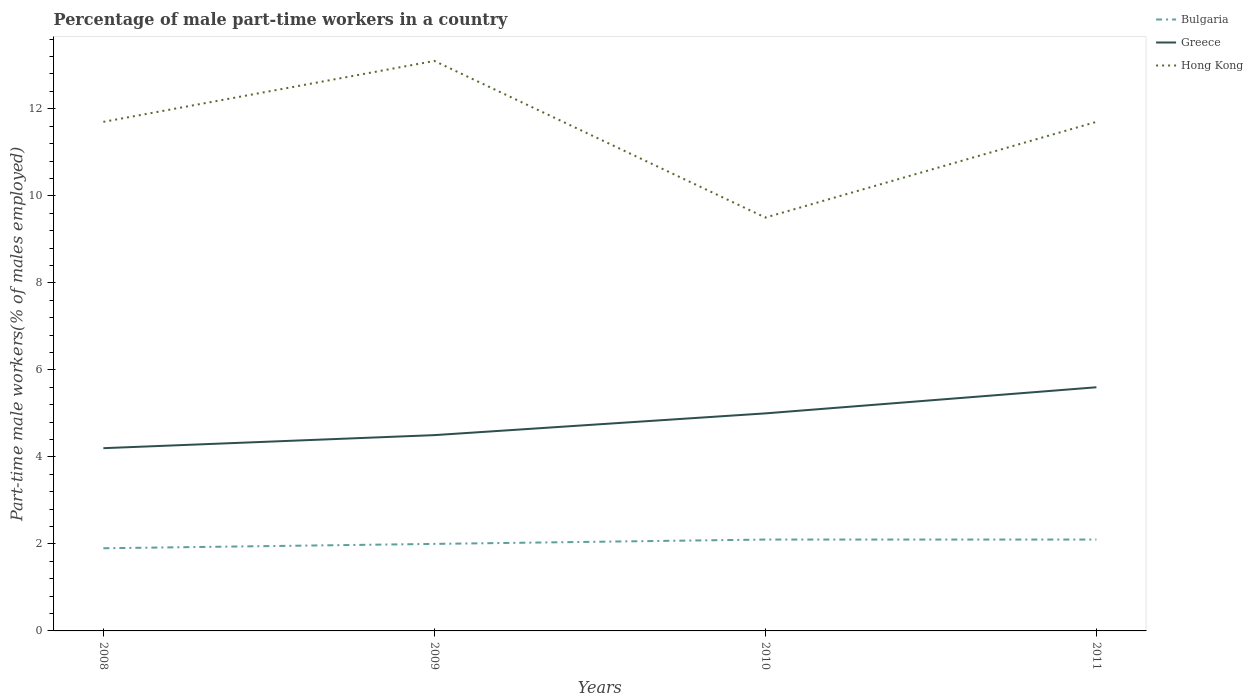How many different coloured lines are there?
Keep it short and to the point. 3. Does the line corresponding to Bulgaria intersect with the line corresponding to Hong Kong?
Make the answer very short. No. Is the number of lines equal to the number of legend labels?
Ensure brevity in your answer.  Yes. Across all years, what is the maximum percentage of male part-time workers in Bulgaria?
Ensure brevity in your answer.  1.9. In which year was the percentage of male part-time workers in Bulgaria maximum?
Your answer should be very brief. 2008. What is the total percentage of male part-time workers in Hong Kong in the graph?
Keep it short and to the point. 1.4. What is the difference between the highest and the second highest percentage of male part-time workers in Greece?
Provide a short and direct response. 1.4. How many years are there in the graph?
Offer a very short reply. 4. Does the graph contain grids?
Your answer should be very brief. No. What is the title of the graph?
Give a very brief answer. Percentage of male part-time workers in a country. What is the label or title of the Y-axis?
Your response must be concise. Part-time male workers(% of males employed). What is the Part-time male workers(% of males employed) in Bulgaria in 2008?
Provide a short and direct response. 1.9. What is the Part-time male workers(% of males employed) in Greece in 2008?
Offer a very short reply. 4.2. What is the Part-time male workers(% of males employed) in Hong Kong in 2008?
Provide a short and direct response. 11.7. What is the Part-time male workers(% of males employed) in Bulgaria in 2009?
Provide a short and direct response. 2. What is the Part-time male workers(% of males employed) in Greece in 2009?
Provide a succinct answer. 4.5. What is the Part-time male workers(% of males employed) in Hong Kong in 2009?
Make the answer very short. 13.1. What is the Part-time male workers(% of males employed) in Bulgaria in 2010?
Provide a short and direct response. 2.1. What is the Part-time male workers(% of males employed) of Hong Kong in 2010?
Your answer should be compact. 9.5. What is the Part-time male workers(% of males employed) in Bulgaria in 2011?
Keep it short and to the point. 2.1. What is the Part-time male workers(% of males employed) of Greece in 2011?
Ensure brevity in your answer.  5.6. What is the Part-time male workers(% of males employed) in Hong Kong in 2011?
Provide a short and direct response. 11.7. Across all years, what is the maximum Part-time male workers(% of males employed) in Bulgaria?
Keep it short and to the point. 2.1. Across all years, what is the maximum Part-time male workers(% of males employed) of Greece?
Offer a terse response. 5.6. Across all years, what is the maximum Part-time male workers(% of males employed) in Hong Kong?
Give a very brief answer. 13.1. Across all years, what is the minimum Part-time male workers(% of males employed) of Bulgaria?
Keep it short and to the point. 1.9. Across all years, what is the minimum Part-time male workers(% of males employed) in Greece?
Give a very brief answer. 4.2. What is the total Part-time male workers(% of males employed) of Greece in the graph?
Keep it short and to the point. 19.3. What is the total Part-time male workers(% of males employed) of Hong Kong in the graph?
Make the answer very short. 46. What is the difference between the Part-time male workers(% of males employed) in Greece in 2008 and that in 2009?
Make the answer very short. -0.3. What is the difference between the Part-time male workers(% of males employed) of Bulgaria in 2008 and that in 2011?
Provide a short and direct response. -0.2. What is the difference between the Part-time male workers(% of males employed) in Bulgaria in 2009 and that in 2010?
Your answer should be very brief. -0.1. What is the difference between the Part-time male workers(% of males employed) in Hong Kong in 2009 and that in 2010?
Offer a terse response. 3.6. What is the difference between the Part-time male workers(% of males employed) of Bulgaria in 2009 and that in 2011?
Provide a short and direct response. -0.1. What is the difference between the Part-time male workers(% of males employed) of Hong Kong in 2009 and that in 2011?
Provide a short and direct response. 1.4. What is the difference between the Part-time male workers(% of males employed) in Bulgaria in 2010 and that in 2011?
Your answer should be compact. 0. What is the difference between the Part-time male workers(% of males employed) of Greece in 2010 and that in 2011?
Provide a succinct answer. -0.6. What is the difference between the Part-time male workers(% of males employed) in Hong Kong in 2010 and that in 2011?
Your response must be concise. -2.2. What is the difference between the Part-time male workers(% of males employed) in Greece in 2008 and the Part-time male workers(% of males employed) in Hong Kong in 2009?
Offer a terse response. -8.9. What is the difference between the Part-time male workers(% of males employed) of Bulgaria in 2008 and the Part-time male workers(% of males employed) of Greece in 2010?
Your response must be concise. -3.1. What is the difference between the Part-time male workers(% of males employed) of Bulgaria in 2009 and the Part-time male workers(% of males employed) of Greece in 2010?
Your response must be concise. -3. What is the difference between the Part-time male workers(% of males employed) of Bulgaria in 2009 and the Part-time male workers(% of males employed) of Hong Kong in 2010?
Provide a short and direct response. -7.5. What is the difference between the Part-time male workers(% of males employed) of Greece in 2009 and the Part-time male workers(% of males employed) of Hong Kong in 2010?
Offer a very short reply. -5. What is the difference between the Part-time male workers(% of males employed) of Bulgaria in 2010 and the Part-time male workers(% of males employed) of Greece in 2011?
Provide a succinct answer. -3.5. What is the difference between the Part-time male workers(% of males employed) in Bulgaria in 2010 and the Part-time male workers(% of males employed) in Hong Kong in 2011?
Make the answer very short. -9.6. What is the average Part-time male workers(% of males employed) in Bulgaria per year?
Provide a succinct answer. 2.02. What is the average Part-time male workers(% of males employed) of Greece per year?
Your response must be concise. 4.83. What is the average Part-time male workers(% of males employed) of Hong Kong per year?
Keep it short and to the point. 11.5. In the year 2008, what is the difference between the Part-time male workers(% of males employed) in Bulgaria and Part-time male workers(% of males employed) in Hong Kong?
Ensure brevity in your answer.  -9.8. In the year 2008, what is the difference between the Part-time male workers(% of males employed) in Greece and Part-time male workers(% of males employed) in Hong Kong?
Offer a terse response. -7.5. In the year 2009, what is the difference between the Part-time male workers(% of males employed) of Bulgaria and Part-time male workers(% of males employed) of Greece?
Your answer should be compact. -2.5. In the year 2009, what is the difference between the Part-time male workers(% of males employed) of Greece and Part-time male workers(% of males employed) of Hong Kong?
Make the answer very short. -8.6. In the year 2010, what is the difference between the Part-time male workers(% of males employed) in Bulgaria and Part-time male workers(% of males employed) in Greece?
Your answer should be compact. -2.9. In the year 2011, what is the difference between the Part-time male workers(% of males employed) in Bulgaria and Part-time male workers(% of males employed) in Greece?
Keep it short and to the point. -3.5. In the year 2011, what is the difference between the Part-time male workers(% of males employed) in Bulgaria and Part-time male workers(% of males employed) in Hong Kong?
Offer a terse response. -9.6. What is the ratio of the Part-time male workers(% of males employed) of Bulgaria in 2008 to that in 2009?
Provide a short and direct response. 0.95. What is the ratio of the Part-time male workers(% of males employed) in Hong Kong in 2008 to that in 2009?
Give a very brief answer. 0.89. What is the ratio of the Part-time male workers(% of males employed) in Bulgaria in 2008 to that in 2010?
Make the answer very short. 0.9. What is the ratio of the Part-time male workers(% of males employed) in Greece in 2008 to that in 2010?
Offer a terse response. 0.84. What is the ratio of the Part-time male workers(% of males employed) of Hong Kong in 2008 to that in 2010?
Your answer should be compact. 1.23. What is the ratio of the Part-time male workers(% of males employed) in Bulgaria in 2008 to that in 2011?
Provide a succinct answer. 0.9. What is the ratio of the Part-time male workers(% of males employed) in Hong Kong in 2009 to that in 2010?
Offer a terse response. 1.38. What is the ratio of the Part-time male workers(% of males employed) in Bulgaria in 2009 to that in 2011?
Offer a terse response. 0.95. What is the ratio of the Part-time male workers(% of males employed) of Greece in 2009 to that in 2011?
Provide a short and direct response. 0.8. What is the ratio of the Part-time male workers(% of males employed) in Hong Kong in 2009 to that in 2011?
Make the answer very short. 1.12. What is the ratio of the Part-time male workers(% of males employed) in Bulgaria in 2010 to that in 2011?
Offer a terse response. 1. What is the ratio of the Part-time male workers(% of males employed) in Greece in 2010 to that in 2011?
Your answer should be compact. 0.89. What is the ratio of the Part-time male workers(% of males employed) of Hong Kong in 2010 to that in 2011?
Keep it short and to the point. 0.81. What is the difference between the highest and the second highest Part-time male workers(% of males employed) of Greece?
Your answer should be compact. 0.6. What is the difference between the highest and the second highest Part-time male workers(% of males employed) in Hong Kong?
Ensure brevity in your answer.  1.4. What is the difference between the highest and the lowest Part-time male workers(% of males employed) of Bulgaria?
Give a very brief answer. 0.2. What is the difference between the highest and the lowest Part-time male workers(% of males employed) of Greece?
Your answer should be very brief. 1.4. 